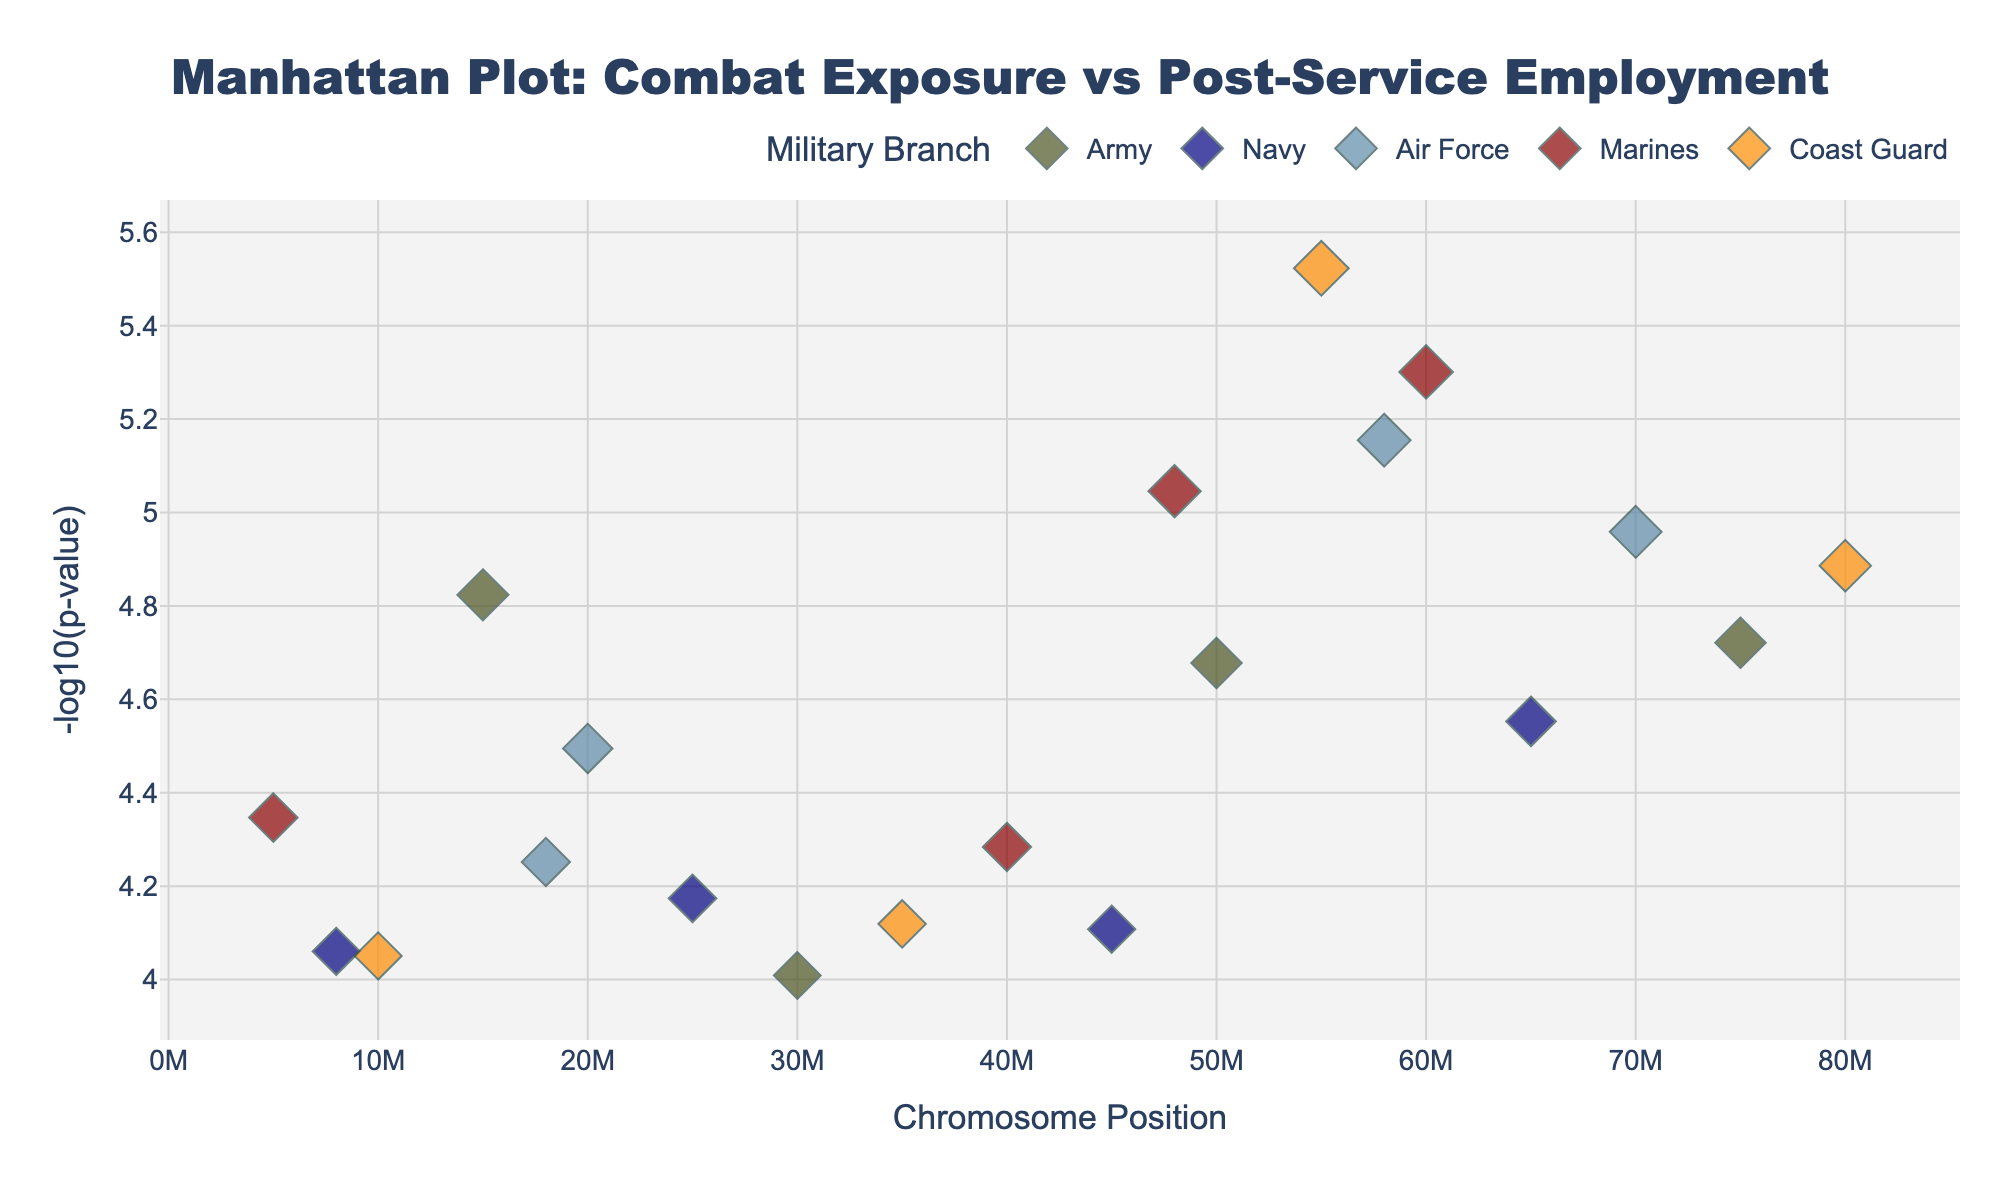What's the title of the plot? The title is displayed prominently at the top of the plot in large, bold font.
Answer: Manhattan Plot: Combat Exposure vs Post-Service Employment How is the y-axis labeled? The y-axis label is located along the vertical axis on the left side of the plot.
Answer: -log10(p-value) What color represents the Air Force in the plot? The color legend shows that Air Force is represented by a specific light blue color.
Answer: Light Blue How many significant data points are there for the Army branch? There are five markers in the plot specifically for the Army, indicated by its unique color.
Answer: Five At what chromosome position does the Coast Guard have the most significant correlation? Look for the smallest p-value (largest -log10(p)) among the Coast Guard markers and note its position.
Answer: 55,000,000 Which branch has the most data points plotted on the graph? Count the number of markers for each branch; the one with the most markers is the answer.
Answer: Army Which branch shows the most significant association, and at what chromosome position? The smallest p-value overall indicates the most significant association; find this and its corresponding branch and position.
Answer: Coast Guard at position 55,000,000 Is the employment correlation more significant for the Marines or the Navy? Compare the highest -log10(p-value) for both Marines and Navy. The one with the higher value indicates a more significant correlation.
Answer: Marines How many data points have a -log10(p-value) greater than 4? Identify and count all markers with a -log10(p) value greater than 4 on the y-axis.
Answer: Nine Which branch has significant data points in Chromosome 7 and which has the highest significance? Identify all branches with markers on Chromosome 7 and compare their -log10(p) values.
Answer: Air Force and Marines, with Marines having the highest significance 